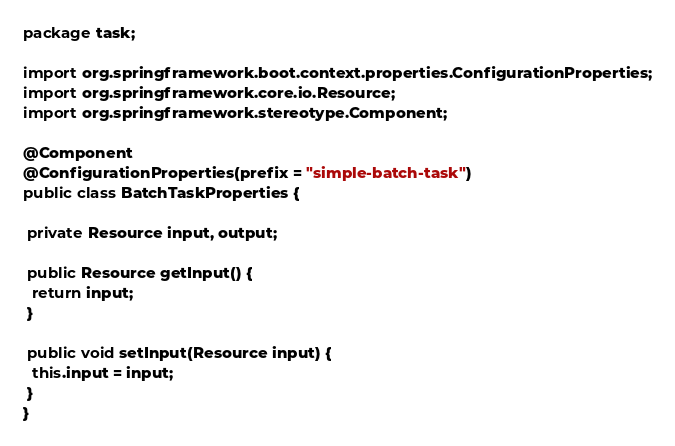<code> <loc_0><loc_0><loc_500><loc_500><_Java_>package task;

import org.springframework.boot.context.properties.ConfigurationProperties;
import org.springframework.core.io.Resource;
import org.springframework.stereotype.Component;

@Component
@ConfigurationProperties(prefix = "simple-batch-task")
public class BatchTaskProperties {

 private Resource input, output;

 public Resource getInput() {
  return input;
 }

 public void setInput(Resource input) {
  this.input = input;
 }
}
</code> 